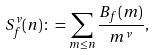Convert formula to latex. <formula><loc_0><loc_0><loc_500><loc_500>S _ { f } ^ { \nu } ( n ) \colon = \sum _ { m \leq n } \frac { B _ { f } ( m ) } { m ^ { \nu } } ,</formula> 